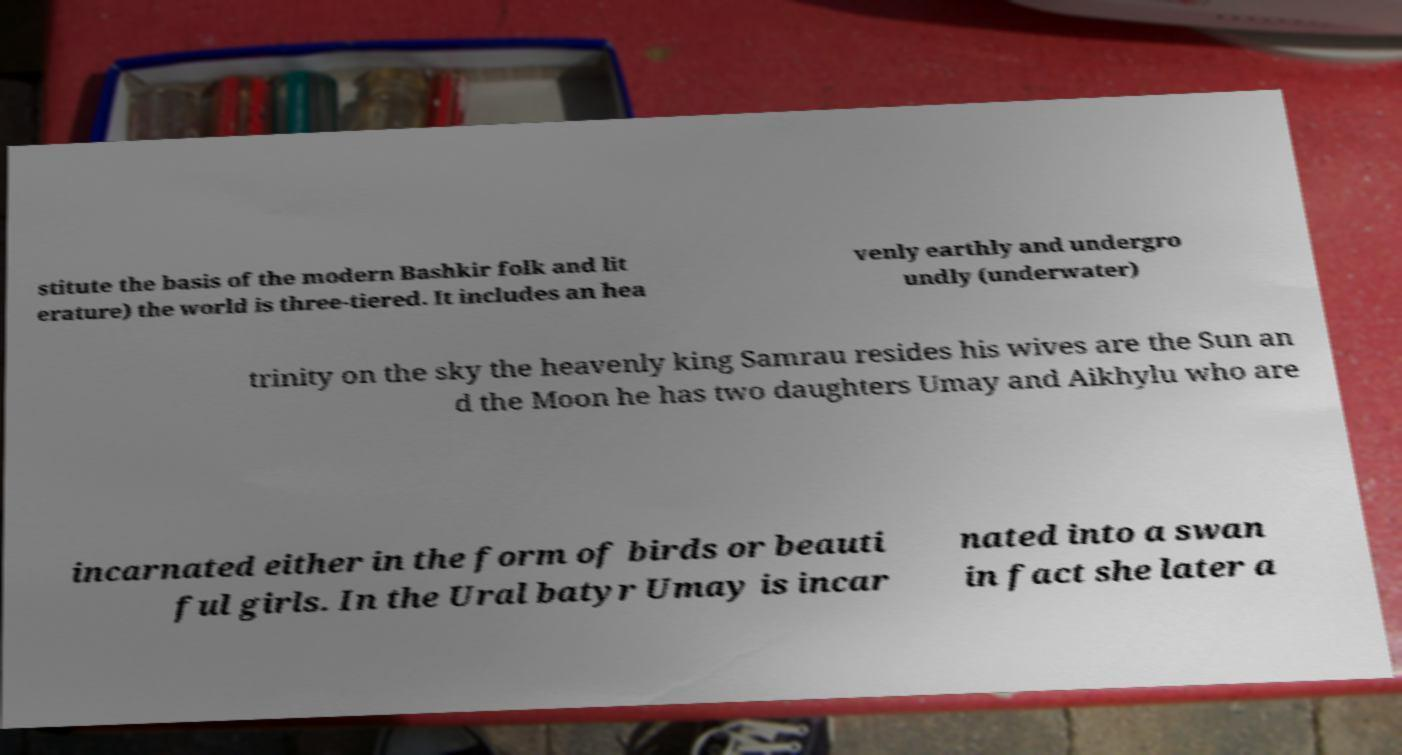Can you read and provide the text displayed in the image?This photo seems to have some interesting text. Can you extract and type it out for me? stitute the basis of the modern Bashkir folk and lit erature) the world is three-tiered. It includes an hea venly earthly and undergro undly (underwater) trinity on the sky the heavenly king Samrau resides his wives are the Sun an d the Moon he has two daughters Umay and Aikhylu who are incarnated either in the form of birds or beauti ful girls. In the Ural batyr Umay is incar nated into a swan in fact she later a 